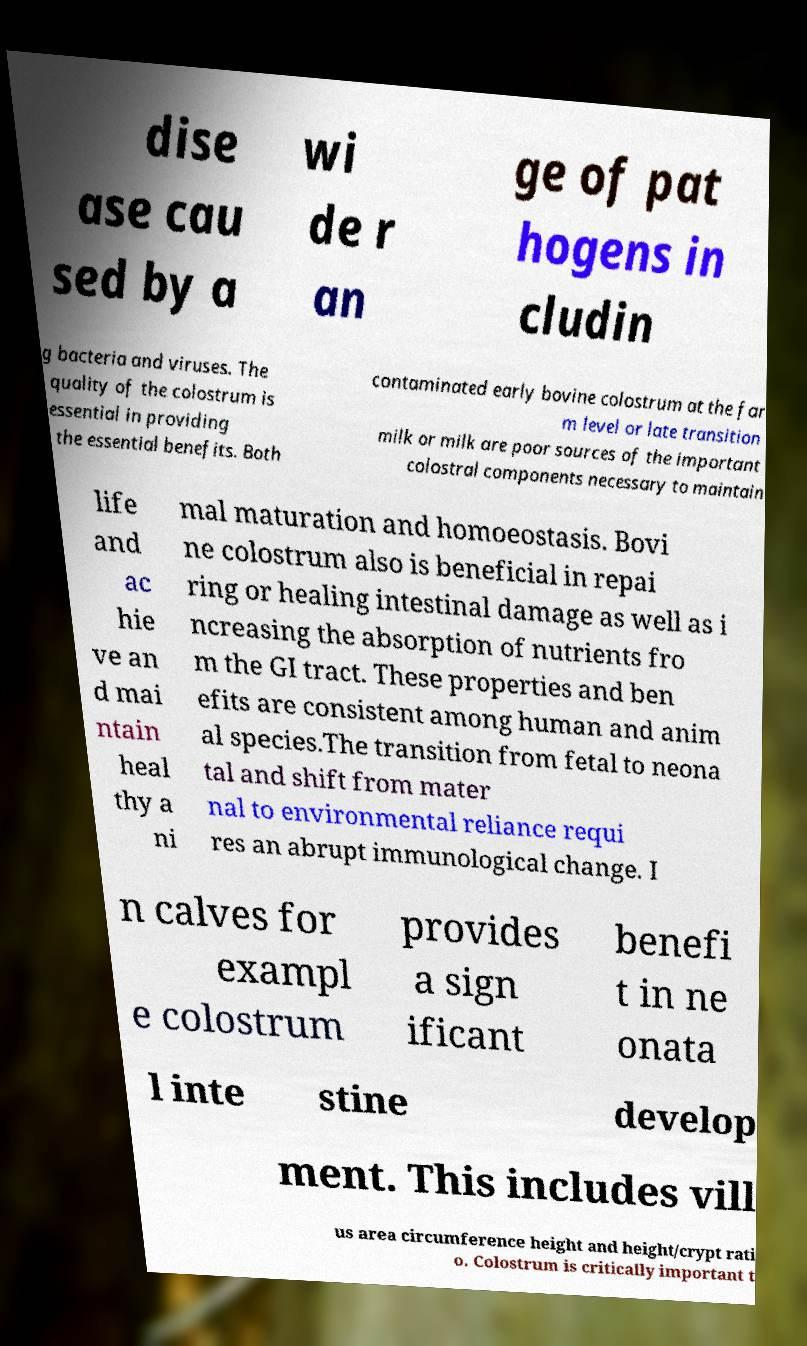For documentation purposes, I need the text within this image transcribed. Could you provide that? dise ase cau sed by a wi de r an ge of pat hogens in cludin g bacteria and viruses. The quality of the colostrum is essential in providing the essential benefits. Both contaminated early bovine colostrum at the far m level or late transition milk or milk are poor sources of the important colostral components necessary to maintain life and ac hie ve an d mai ntain heal thy a ni mal maturation and homoeostasis. Bovi ne colostrum also is beneficial in repai ring or healing intestinal damage as well as i ncreasing the absorption of nutrients fro m the GI tract. These properties and ben efits are consistent among human and anim al species.The transition from fetal to neona tal and shift from mater nal to environmental reliance requi res an abrupt immunological change. I n calves for exampl e colostrum provides a sign ificant benefi t in ne onata l inte stine develop ment. This includes vill us area circumference height and height/crypt rati o. Colostrum is critically important t 